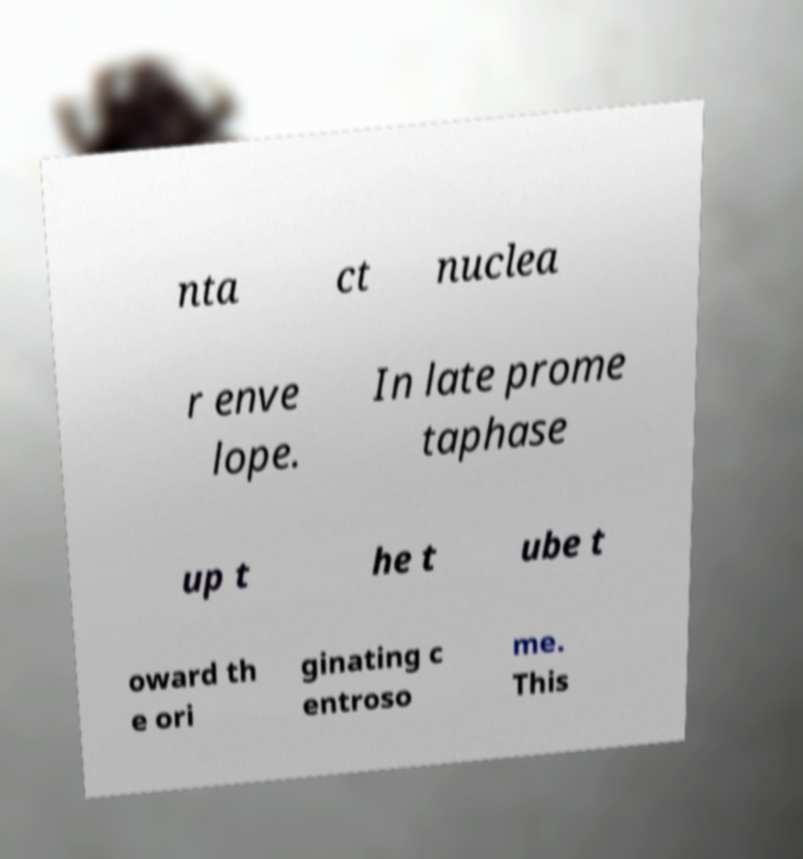Can you read and provide the text displayed in the image?This photo seems to have some interesting text. Can you extract and type it out for me? nta ct nuclea r enve lope. In late prome taphase up t he t ube t oward th e ori ginating c entroso me. This 